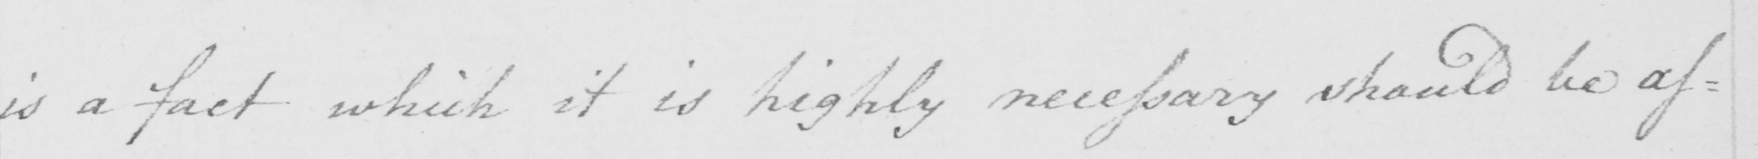What is written in this line of handwriting? is a fact which it is highly necessary should be as : 